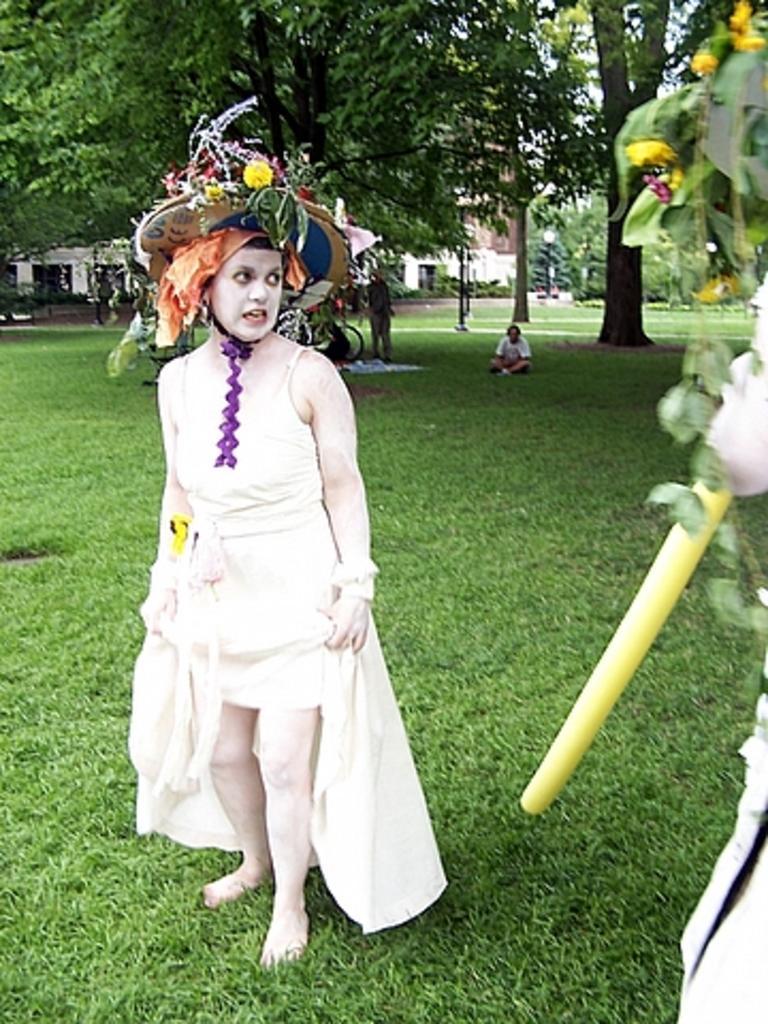In one or two sentences, can you explain what this image depicts? In the picture we can see a woman standing on the grass surface, she is wearing a white dress and white makeup and a hat which is decorated with some leaves and in the background, we can see some trees and some persons standing and one is sitting on the surface and behind we can see a building. 